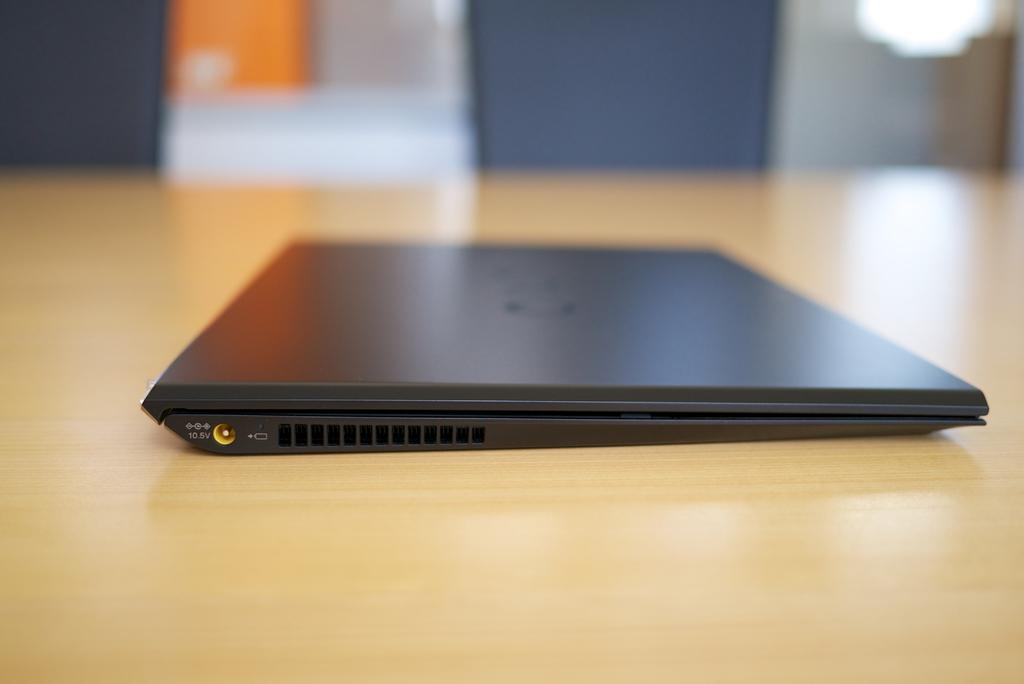What electronic device is visible in the image? There is a laptop in the image. What type of surface is the laptop placed on? The laptop is on a wooden surface. Can you describe the background of the image? The background of the image is blurry. What type of pump is visible in the image? There is no pump present in the image; it features a laptop on a wooden surface with a blurry background. 